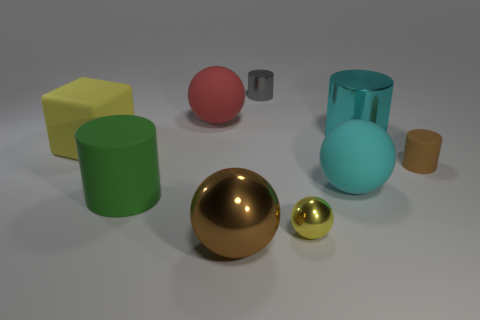There is a rubber ball that is in front of the yellow rubber object; is it the same color as the big shiny cylinder?
Provide a short and direct response. Yes. What material is the thing that is the same color as the big shiny sphere?
Ensure brevity in your answer.  Rubber. There is a object that is the same color as the tiny metallic sphere; what size is it?
Ensure brevity in your answer.  Large. There is a large matte sphere that is in front of the large yellow rubber thing; is it the same color as the large metallic object that is behind the large brown metal ball?
Ensure brevity in your answer.  Yes. Are there any spheres of the same color as the large block?
Your response must be concise. Yes. Is the shape of the big cyan rubber thing the same as the tiny metal object that is in front of the red rubber object?
Make the answer very short. Yes. What is the size of the sphere that is both in front of the large cyan sphere and behind the brown sphere?
Give a very brief answer. Small. What is the color of the sphere that is both on the left side of the gray metal object and in front of the red thing?
Your answer should be very brief. Brown. Is the number of large spheres in front of the big cyan rubber thing less than the number of large red balls in front of the brown rubber thing?
Make the answer very short. No. Is there anything else that is the same color as the small matte cylinder?
Offer a very short reply. Yes. 